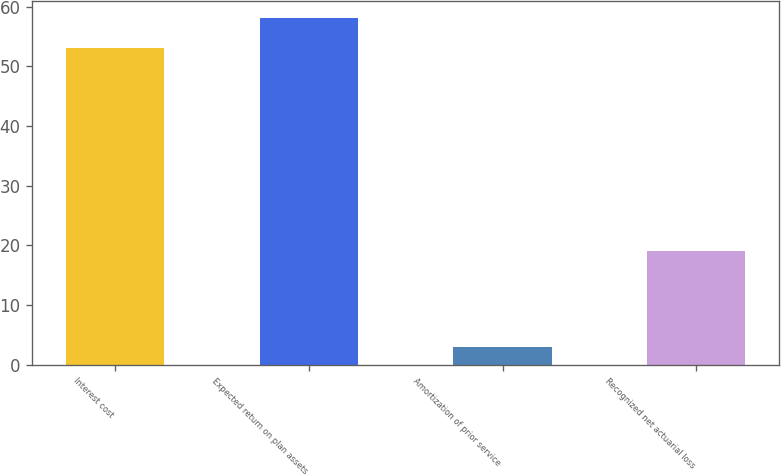<chart> <loc_0><loc_0><loc_500><loc_500><bar_chart><fcel>Interest cost<fcel>Expected return on plan assets<fcel>Amortization of prior service<fcel>Recognized net actuarial loss<nl><fcel>53<fcel>58.1<fcel>3<fcel>19<nl></chart> 